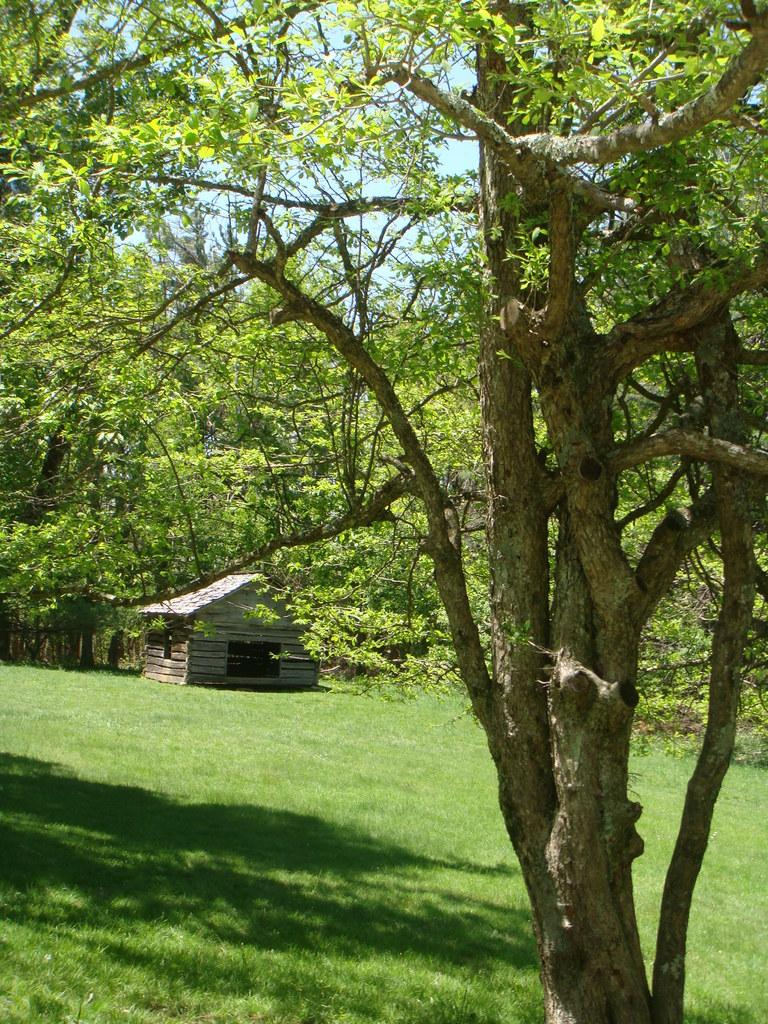What type of structure can be seen in the image? There is a shed in the image. What can be seen beneath the shed? The ground is visible in the image. What type of vegetation is present in the image? There are trees in the image. What is visible above the shed? The sky is visible in the image. Reasoning: Let's think step by step by step in order to produce the conversation. We start by identifying the main structure in the image, which is the shed. Then, we describe the ground beneath the shed and the sky above it. Finally, we mention the presence of trees, which adds to the overall setting of the image. Absurd Question/Answer: How many potatoes can be seen growing near the shed in the image? There are no potatoes visible in the image; it features a shed, ground, trees, and sky. What type of celery is growing next to the shed in the image? There is no celery present in the image; it only features a shed, ground, trees, and sky. What type of celery is growing next to the shed in the image? There is no celery present in the image; it only features a shed, ground, trees, and sky. 